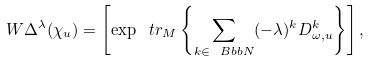<formula> <loc_0><loc_0><loc_500><loc_500>W \Delta ^ { \lambda } ( \chi _ { u } ) = \left [ \exp \ t r _ { M } \left \{ \sum _ { k \in \ B b b { N } } ( - \lambda ) ^ { k } D _ { \omega , u } ^ { k } \right \} \right ] ,</formula> 